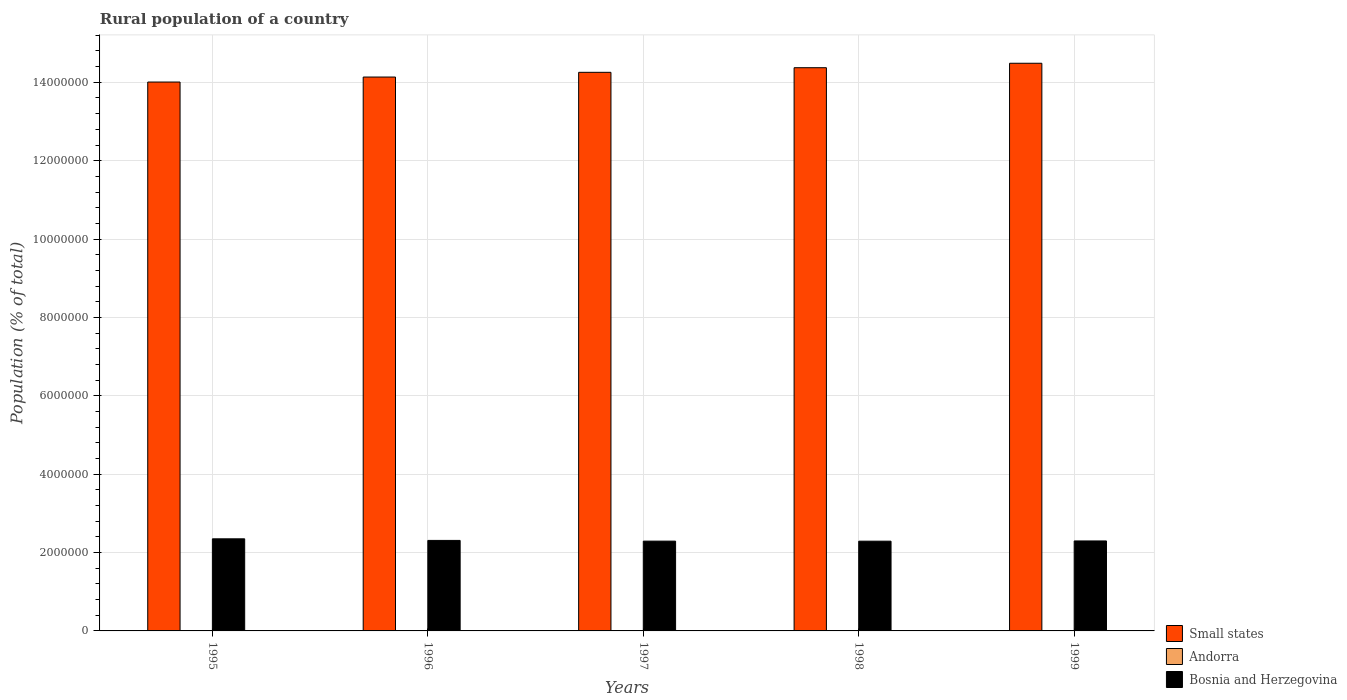How many different coloured bars are there?
Offer a terse response. 3. Are the number of bars per tick equal to the number of legend labels?
Offer a very short reply. Yes. Are the number of bars on each tick of the X-axis equal?
Provide a short and direct response. Yes. How many bars are there on the 2nd tick from the right?
Your answer should be compact. 3. What is the rural population in Bosnia and Herzegovina in 1995?
Give a very brief answer. 2.35e+06. Across all years, what is the maximum rural population in Andorra?
Keep it short and to the point. 4706. Across all years, what is the minimum rural population in Bosnia and Herzegovina?
Ensure brevity in your answer.  2.29e+06. In which year was the rural population in Andorra maximum?
Provide a short and direct response. 1999. What is the total rural population in Small states in the graph?
Your response must be concise. 7.13e+07. What is the difference between the rural population in Small states in 1996 and that in 1997?
Ensure brevity in your answer.  -1.20e+05. What is the difference between the rural population in Andorra in 1998 and the rural population in Small states in 1997?
Keep it short and to the point. -1.43e+07. What is the average rural population in Andorra per year?
Offer a terse response. 4375. In the year 1995, what is the difference between the rural population in Small states and rural population in Bosnia and Herzegovina?
Provide a short and direct response. 1.17e+07. In how many years, is the rural population in Andorra greater than 10400000 %?
Offer a terse response. 0. What is the ratio of the rural population in Bosnia and Herzegovina in 1998 to that in 1999?
Your response must be concise. 1. Is the rural population in Bosnia and Herzegovina in 1996 less than that in 1997?
Ensure brevity in your answer.  No. What is the difference between the highest and the second highest rural population in Bosnia and Herzegovina?
Your answer should be very brief. 4.08e+04. What is the difference between the highest and the lowest rural population in Bosnia and Herzegovina?
Ensure brevity in your answer.  6.03e+04. In how many years, is the rural population in Small states greater than the average rural population in Small states taken over all years?
Give a very brief answer. 3. What does the 1st bar from the left in 1995 represents?
Provide a succinct answer. Small states. What does the 3rd bar from the right in 1996 represents?
Provide a succinct answer. Small states. Is it the case that in every year, the sum of the rural population in Andorra and rural population in Small states is greater than the rural population in Bosnia and Herzegovina?
Keep it short and to the point. Yes. Are all the bars in the graph horizontal?
Keep it short and to the point. No. What is the difference between two consecutive major ticks on the Y-axis?
Offer a very short reply. 2.00e+06. Does the graph contain any zero values?
Provide a short and direct response. No. Does the graph contain grids?
Offer a very short reply. Yes. How many legend labels are there?
Ensure brevity in your answer.  3. What is the title of the graph?
Provide a succinct answer. Rural population of a country. What is the label or title of the X-axis?
Give a very brief answer. Years. What is the label or title of the Y-axis?
Make the answer very short. Population (% of total). What is the Population (% of total) in Small states in 1995?
Offer a terse response. 1.40e+07. What is the Population (% of total) of Andorra in 1995?
Your answer should be compact. 4048. What is the Population (% of total) in Bosnia and Herzegovina in 1995?
Your answer should be compact. 2.35e+06. What is the Population (% of total) of Small states in 1996?
Provide a succinct answer. 1.41e+07. What is the Population (% of total) of Andorra in 1996?
Keep it short and to the point. 4227. What is the Population (% of total) in Bosnia and Herzegovina in 1996?
Offer a terse response. 2.31e+06. What is the Population (% of total) in Small states in 1997?
Make the answer very short. 1.43e+07. What is the Population (% of total) in Andorra in 1997?
Give a very brief answer. 4375. What is the Population (% of total) of Bosnia and Herzegovina in 1997?
Your answer should be very brief. 2.29e+06. What is the Population (% of total) in Small states in 1998?
Ensure brevity in your answer.  1.44e+07. What is the Population (% of total) in Andorra in 1998?
Your answer should be compact. 4519. What is the Population (% of total) of Bosnia and Herzegovina in 1998?
Your response must be concise. 2.29e+06. What is the Population (% of total) of Small states in 1999?
Your answer should be compact. 1.45e+07. What is the Population (% of total) in Andorra in 1999?
Provide a short and direct response. 4706. What is the Population (% of total) of Bosnia and Herzegovina in 1999?
Your answer should be very brief. 2.30e+06. Across all years, what is the maximum Population (% of total) in Small states?
Offer a very short reply. 1.45e+07. Across all years, what is the maximum Population (% of total) of Andorra?
Your answer should be very brief. 4706. Across all years, what is the maximum Population (% of total) of Bosnia and Herzegovina?
Your response must be concise. 2.35e+06. Across all years, what is the minimum Population (% of total) of Small states?
Ensure brevity in your answer.  1.40e+07. Across all years, what is the minimum Population (% of total) of Andorra?
Your answer should be very brief. 4048. Across all years, what is the minimum Population (% of total) in Bosnia and Herzegovina?
Provide a short and direct response. 2.29e+06. What is the total Population (% of total) in Small states in the graph?
Offer a very short reply. 7.13e+07. What is the total Population (% of total) of Andorra in the graph?
Offer a terse response. 2.19e+04. What is the total Population (% of total) of Bosnia and Herzegovina in the graph?
Your answer should be compact. 1.15e+07. What is the difference between the Population (% of total) of Small states in 1995 and that in 1996?
Provide a succinct answer. -1.28e+05. What is the difference between the Population (% of total) of Andorra in 1995 and that in 1996?
Keep it short and to the point. -179. What is the difference between the Population (% of total) in Bosnia and Herzegovina in 1995 and that in 1996?
Ensure brevity in your answer.  4.08e+04. What is the difference between the Population (% of total) in Small states in 1995 and that in 1997?
Offer a very short reply. -2.48e+05. What is the difference between the Population (% of total) in Andorra in 1995 and that in 1997?
Provide a short and direct response. -327. What is the difference between the Population (% of total) in Bosnia and Herzegovina in 1995 and that in 1997?
Your answer should be compact. 5.90e+04. What is the difference between the Population (% of total) in Small states in 1995 and that in 1998?
Your response must be concise. -3.66e+05. What is the difference between the Population (% of total) in Andorra in 1995 and that in 1998?
Your answer should be compact. -471. What is the difference between the Population (% of total) of Bosnia and Herzegovina in 1995 and that in 1998?
Offer a terse response. 6.03e+04. What is the difference between the Population (% of total) of Small states in 1995 and that in 1999?
Your response must be concise. -4.79e+05. What is the difference between the Population (% of total) in Andorra in 1995 and that in 1999?
Ensure brevity in your answer.  -658. What is the difference between the Population (% of total) in Bosnia and Herzegovina in 1995 and that in 1999?
Your response must be concise. 5.43e+04. What is the difference between the Population (% of total) in Small states in 1996 and that in 1997?
Give a very brief answer. -1.20e+05. What is the difference between the Population (% of total) of Andorra in 1996 and that in 1997?
Make the answer very short. -148. What is the difference between the Population (% of total) of Bosnia and Herzegovina in 1996 and that in 1997?
Keep it short and to the point. 1.82e+04. What is the difference between the Population (% of total) of Small states in 1996 and that in 1998?
Provide a succinct answer. -2.38e+05. What is the difference between the Population (% of total) in Andorra in 1996 and that in 1998?
Provide a succinct answer. -292. What is the difference between the Population (% of total) in Bosnia and Herzegovina in 1996 and that in 1998?
Keep it short and to the point. 1.95e+04. What is the difference between the Population (% of total) of Small states in 1996 and that in 1999?
Your answer should be compact. -3.52e+05. What is the difference between the Population (% of total) of Andorra in 1996 and that in 1999?
Your response must be concise. -479. What is the difference between the Population (% of total) of Bosnia and Herzegovina in 1996 and that in 1999?
Provide a short and direct response. 1.35e+04. What is the difference between the Population (% of total) in Small states in 1997 and that in 1998?
Offer a very short reply. -1.18e+05. What is the difference between the Population (% of total) in Andorra in 1997 and that in 1998?
Give a very brief answer. -144. What is the difference between the Population (% of total) of Bosnia and Herzegovina in 1997 and that in 1998?
Provide a succinct answer. 1302. What is the difference between the Population (% of total) in Small states in 1997 and that in 1999?
Provide a short and direct response. -2.31e+05. What is the difference between the Population (% of total) in Andorra in 1997 and that in 1999?
Provide a succinct answer. -331. What is the difference between the Population (% of total) in Bosnia and Herzegovina in 1997 and that in 1999?
Your response must be concise. -4642. What is the difference between the Population (% of total) of Small states in 1998 and that in 1999?
Your response must be concise. -1.13e+05. What is the difference between the Population (% of total) in Andorra in 1998 and that in 1999?
Your response must be concise. -187. What is the difference between the Population (% of total) in Bosnia and Herzegovina in 1998 and that in 1999?
Your response must be concise. -5944. What is the difference between the Population (% of total) of Small states in 1995 and the Population (% of total) of Andorra in 1996?
Keep it short and to the point. 1.40e+07. What is the difference between the Population (% of total) of Small states in 1995 and the Population (% of total) of Bosnia and Herzegovina in 1996?
Offer a very short reply. 1.17e+07. What is the difference between the Population (% of total) of Andorra in 1995 and the Population (% of total) of Bosnia and Herzegovina in 1996?
Give a very brief answer. -2.31e+06. What is the difference between the Population (% of total) of Small states in 1995 and the Population (% of total) of Andorra in 1997?
Provide a succinct answer. 1.40e+07. What is the difference between the Population (% of total) in Small states in 1995 and the Population (% of total) in Bosnia and Herzegovina in 1997?
Provide a succinct answer. 1.17e+07. What is the difference between the Population (% of total) of Andorra in 1995 and the Population (% of total) of Bosnia and Herzegovina in 1997?
Keep it short and to the point. -2.29e+06. What is the difference between the Population (% of total) in Small states in 1995 and the Population (% of total) in Andorra in 1998?
Your answer should be very brief. 1.40e+07. What is the difference between the Population (% of total) of Small states in 1995 and the Population (% of total) of Bosnia and Herzegovina in 1998?
Offer a very short reply. 1.17e+07. What is the difference between the Population (% of total) of Andorra in 1995 and the Population (% of total) of Bosnia and Herzegovina in 1998?
Your answer should be very brief. -2.29e+06. What is the difference between the Population (% of total) in Small states in 1995 and the Population (% of total) in Andorra in 1999?
Provide a succinct answer. 1.40e+07. What is the difference between the Population (% of total) in Small states in 1995 and the Population (% of total) in Bosnia and Herzegovina in 1999?
Offer a terse response. 1.17e+07. What is the difference between the Population (% of total) of Andorra in 1995 and the Population (% of total) of Bosnia and Herzegovina in 1999?
Your response must be concise. -2.29e+06. What is the difference between the Population (% of total) in Small states in 1996 and the Population (% of total) in Andorra in 1997?
Ensure brevity in your answer.  1.41e+07. What is the difference between the Population (% of total) of Small states in 1996 and the Population (% of total) of Bosnia and Herzegovina in 1997?
Offer a very short reply. 1.18e+07. What is the difference between the Population (% of total) of Andorra in 1996 and the Population (% of total) of Bosnia and Herzegovina in 1997?
Your response must be concise. -2.29e+06. What is the difference between the Population (% of total) in Small states in 1996 and the Population (% of total) in Andorra in 1998?
Make the answer very short. 1.41e+07. What is the difference between the Population (% of total) in Small states in 1996 and the Population (% of total) in Bosnia and Herzegovina in 1998?
Offer a terse response. 1.18e+07. What is the difference between the Population (% of total) of Andorra in 1996 and the Population (% of total) of Bosnia and Herzegovina in 1998?
Your answer should be very brief. -2.29e+06. What is the difference between the Population (% of total) of Small states in 1996 and the Population (% of total) of Andorra in 1999?
Offer a very short reply. 1.41e+07. What is the difference between the Population (% of total) in Small states in 1996 and the Population (% of total) in Bosnia and Herzegovina in 1999?
Offer a very short reply. 1.18e+07. What is the difference between the Population (% of total) of Andorra in 1996 and the Population (% of total) of Bosnia and Herzegovina in 1999?
Make the answer very short. -2.29e+06. What is the difference between the Population (% of total) of Small states in 1997 and the Population (% of total) of Andorra in 1998?
Your answer should be very brief. 1.43e+07. What is the difference between the Population (% of total) of Small states in 1997 and the Population (% of total) of Bosnia and Herzegovina in 1998?
Make the answer very short. 1.20e+07. What is the difference between the Population (% of total) of Andorra in 1997 and the Population (% of total) of Bosnia and Herzegovina in 1998?
Offer a terse response. -2.29e+06. What is the difference between the Population (% of total) in Small states in 1997 and the Population (% of total) in Andorra in 1999?
Give a very brief answer. 1.43e+07. What is the difference between the Population (% of total) of Small states in 1997 and the Population (% of total) of Bosnia and Herzegovina in 1999?
Offer a terse response. 1.20e+07. What is the difference between the Population (% of total) in Andorra in 1997 and the Population (% of total) in Bosnia and Herzegovina in 1999?
Give a very brief answer. -2.29e+06. What is the difference between the Population (% of total) in Small states in 1998 and the Population (% of total) in Andorra in 1999?
Your answer should be very brief. 1.44e+07. What is the difference between the Population (% of total) of Small states in 1998 and the Population (% of total) of Bosnia and Herzegovina in 1999?
Provide a short and direct response. 1.21e+07. What is the difference between the Population (% of total) in Andorra in 1998 and the Population (% of total) in Bosnia and Herzegovina in 1999?
Keep it short and to the point. -2.29e+06. What is the average Population (% of total) in Small states per year?
Make the answer very short. 1.43e+07. What is the average Population (% of total) in Andorra per year?
Your answer should be very brief. 4375. What is the average Population (% of total) of Bosnia and Herzegovina per year?
Offer a terse response. 2.31e+06. In the year 1995, what is the difference between the Population (% of total) of Small states and Population (% of total) of Andorra?
Give a very brief answer. 1.40e+07. In the year 1995, what is the difference between the Population (% of total) of Small states and Population (% of total) of Bosnia and Herzegovina?
Offer a terse response. 1.17e+07. In the year 1995, what is the difference between the Population (% of total) of Andorra and Population (% of total) of Bosnia and Herzegovina?
Keep it short and to the point. -2.35e+06. In the year 1996, what is the difference between the Population (% of total) of Small states and Population (% of total) of Andorra?
Provide a short and direct response. 1.41e+07. In the year 1996, what is the difference between the Population (% of total) of Small states and Population (% of total) of Bosnia and Herzegovina?
Offer a very short reply. 1.18e+07. In the year 1996, what is the difference between the Population (% of total) of Andorra and Population (% of total) of Bosnia and Herzegovina?
Offer a terse response. -2.31e+06. In the year 1997, what is the difference between the Population (% of total) of Small states and Population (% of total) of Andorra?
Offer a terse response. 1.43e+07. In the year 1997, what is the difference between the Population (% of total) of Small states and Population (% of total) of Bosnia and Herzegovina?
Make the answer very short. 1.20e+07. In the year 1997, what is the difference between the Population (% of total) of Andorra and Population (% of total) of Bosnia and Herzegovina?
Offer a very short reply. -2.29e+06. In the year 1998, what is the difference between the Population (% of total) of Small states and Population (% of total) of Andorra?
Ensure brevity in your answer.  1.44e+07. In the year 1998, what is the difference between the Population (% of total) in Small states and Population (% of total) in Bosnia and Herzegovina?
Your response must be concise. 1.21e+07. In the year 1998, what is the difference between the Population (% of total) of Andorra and Population (% of total) of Bosnia and Herzegovina?
Keep it short and to the point. -2.29e+06. In the year 1999, what is the difference between the Population (% of total) of Small states and Population (% of total) of Andorra?
Your answer should be compact. 1.45e+07. In the year 1999, what is the difference between the Population (% of total) of Small states and Population (% of total) of Bosnia and Herzegovina?
Offer a terse response. 1.22e+07. In the year 1999, what is the difference between the Population (% of total) of Andorra and Population (% of total) of Bosnia and Herzegovina?
Provide a succinct answer. -2.29e+06. What is the ratio of the Population (% of total) in Andorra in 1995 to that in 1996?
Provide a short and direct response. 0.96. What is the ratio of the Population (% of total) of Bosnia and Herzegovina in 1995 to that in 1996?
Your response must be concise. 1.02. What is the ratio of the Population (% of total) in Small states in 1995 to that in 1997?
Your answer should be compact. 0.98. What is the ratio of the Population (% of total) of Andorra in 1995 to that in 1997?
Your answer should be very brief. 0.93. What is the ratio of the Population (% of total) in Bosnia and Herzegovina in 1995 to that in 1997?
Your answer should be compact. 1.03. What is the ratio of the Population (% of total) in Small states in 1995 to that in 1998?
Keep it short and to the point. 0.97. What is the ratio of the Population (% of total) in Andorra in 1995 to that in 1998?
Ensure brevity in your answer.  0.9. What is the ratio of the Population (% of total) in Bosnia and Herzegovina in 1995 to that in 1998?
Offer a very short reply. 1.03. What is the ratio of the Population (% of total) in Small states in 1995 to that in 1999?
Your response must be concise. 0.97. What is the ratio of the Population (% of total) of Andorra in 1995 to that in 1999?
Your answer should be very brief. 0.86. What is the ratio of the Population (% of total) of Bosnia and Herzegovina in 1995 to that in 1999?
Offer a very short reply. 1.02. What is the ratio of the Population (% of total) of Small states in 1996 to that in 1997?
Give a very brief answer. 0.99. What is the ratio of the Population (% of total) in Andorra in 1996 to that in 1997?
Make the answer very short. 0.97. What is the ratio of the Population (% of total) in Bosnia and Herzegovina in 1996 to that in 1997?
Provide a succinct answer. 1.01. What is the ratio of the Population (% of total) of Small states in 1996 to that in 1998?
Provide a succinct answer. 0.98. What is the ratio of the Population (% of total) in Andorra in 1996 to that in 1998?
Your answer should be compact. 0.94. What is the ratio of the Population (% of total) of Bosnia and Herzegovina in 1996 to that in 1998?
Provide a succinct answer. 1.01. What is the ratio of the Population (% of total) in Small states in 1996 to that in 1999?
Your answer should be very brief. 0.98. What is the ratio of the Population (% of total) in Andorra in 1996 to that in 1999?
Your answer should be compact. 0.9. What is the ratio of the Population (% of total) of Bosnia and Herzegovina in 1996 to that in 1999?
Keep it short and to the point. 1.01. What is the ratio of the Population (% of total) of Andorra in 1997 to that in 1998?
Offer a very short reply. 0.97. What is the ratio of the Population (% of total) of Bosnia and Herzegovina in 1997 to that in 1998?
Provide a short and direct response. 1. What is the ratio of the Population (% of total) in Andorra in 1997 to that in 1999?
Offer a very short reply. 0.93. What is the ratio of the Population (% of total) in Bosnia and Herzegovina in 1997 to that in 1999?
Your response must be concise. 1. What is the ratio of the Population (% of total) of Small states in 1998 to that in 1999?
Provide a succinct answer. 0.99. What is the ratio of the Population (% of total) in Andorra in 1998 to that in 1999?
Provide a succinct answer. 0.96. What is the difference between the highest and the second highest Population (% of total) in Small states?
Your answer should be very brief. 1.13e+05. What is the difference between the highest and the second highest Population (% of total) of Andorra?
Give a very brief answer. 187. What is the difference between the highest and the second highest Population (% of total) in Bosnia and Herzegovina?
Give a very brief answer. 4.08e+04. What is the difference between the highest and the lowest Population (% of total) in Small states?
Your answer should be compact. 4.79e+05. What is the difference between the highest and the lowest Population (% of total) in Andorra?
Ensure brevity in your answer.  658. What is the difference between the highest and the lowest Population (% of total) in Bosnia and Herzegovina?
Offer a very short reply. 6.03e+04. 